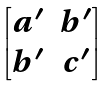Convert formula to latex. <formula><loc_0><loc_0><loc_500><loc_500>\begin{bmatrix} a ^ { \prime } & b ^ { \prime } \\ b ^ { \prime } & c ^ { \prime } \end{bmatrix}</formula> 